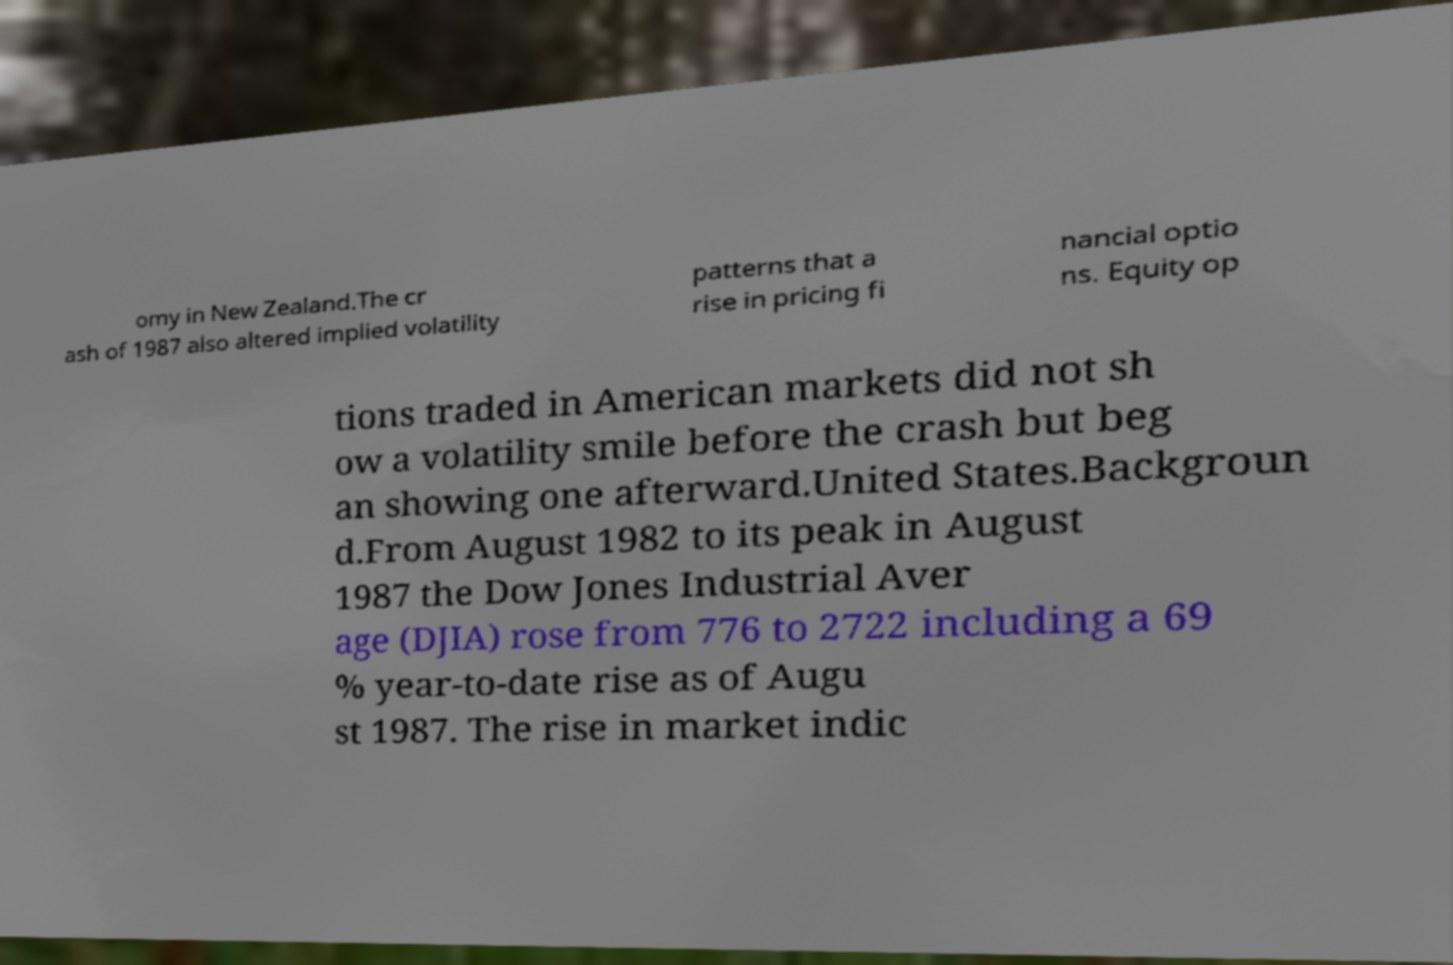Could you extract and type out the text from this image? omy in New Zealand.The cr ash of 1987 also altered implied volatility patterns that a rise in pricing fi nancial optio ns. Equity op tions traded in American markets did not sh ow a volatility smile before the crash but beg an showing one afterward.United States.Backgroun d.From August 1982 to its peak in August 1987 the Dow Jones Industrial Aver age (DJIA) rose from 776 to 2722 including a 69 % year-to-date rise as of Augu st 1987. The rise in market indic 